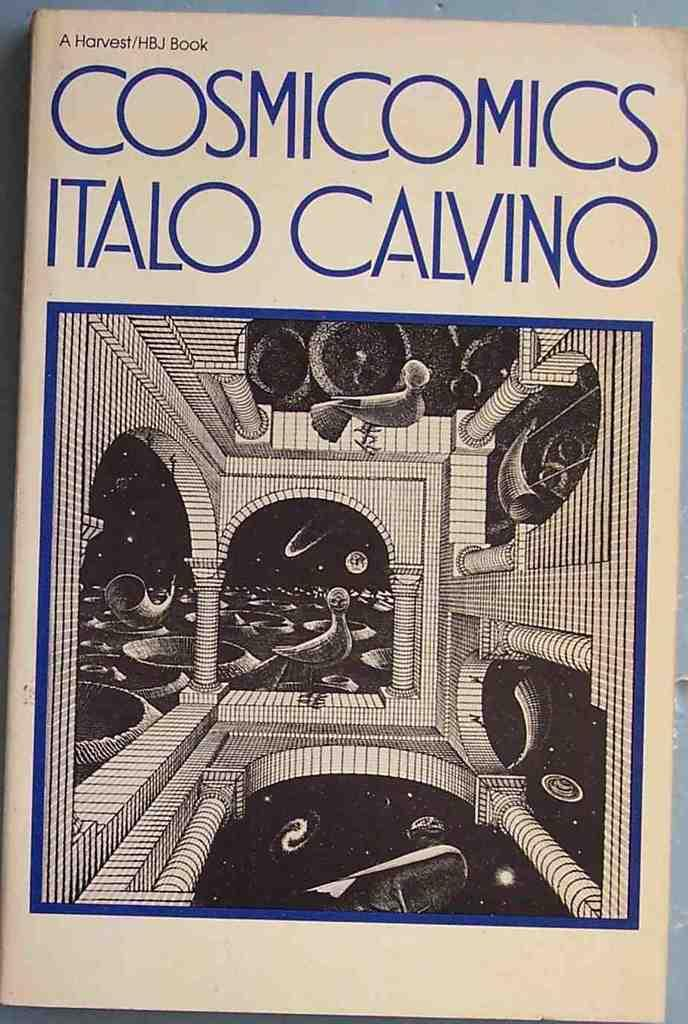Provide a one-sentence caption for the provided image. A well handled book entitled Cosmicomics that contains interesting drawings. 